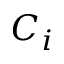Convert formula to latex. <formula><loc_0><loc_0><loc_500><loc_500>C _ { i }</formula> 